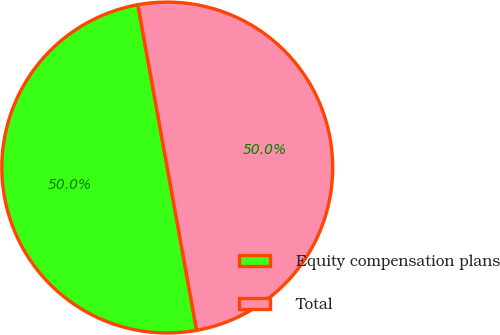Convert chart to OTSL. <chart><loc_0><loc_0><loc_500><loc_500><pie_chart><fcel>Equity compensation plans<fcel>Total<nl><fcel>50.0%<fcel>50.0%<nl></chart> 